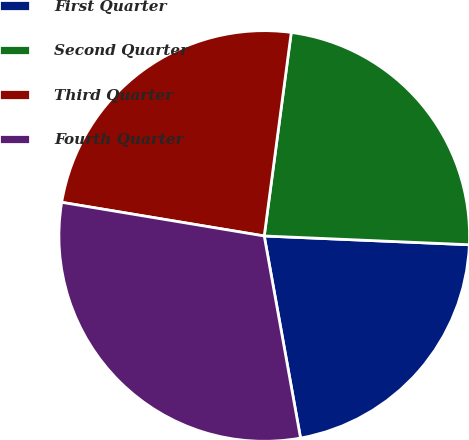Convert chart to OTSL. <chart><loc_0><loc_0><loc_500><loc_500><pie_chart><fcel>First Quarter<fcel>Second Quarter<fcel>Third Quarter<fcel>Fourth Quarter<nl><fcel>21.49%<fcel>23.58%<fcel>24.48%<fcel>30.45%<nl></chart> 